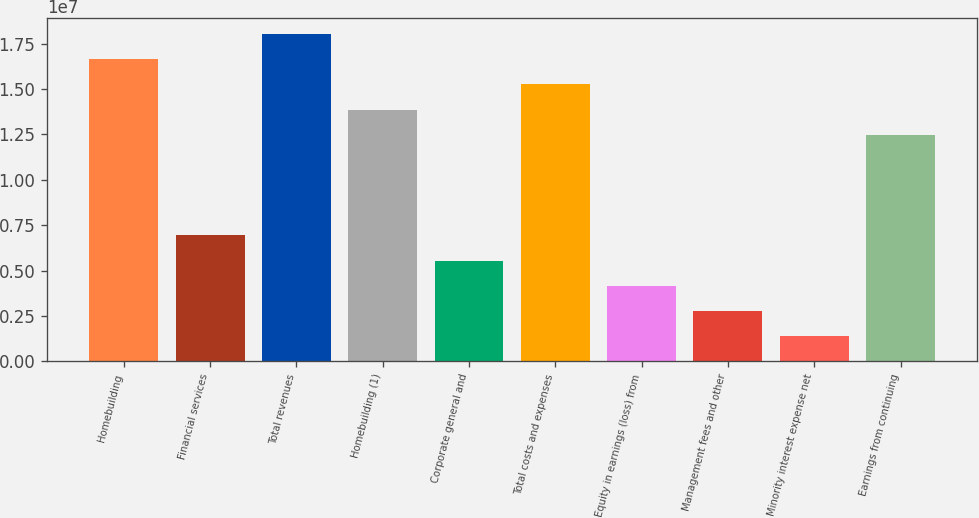Convert chart. <chart><loc_0><loc_0><loc_500><loc_500><bar_chart><fcel>Homebuilding<fcel>Financial services<fcel>Total revenues<fcel>Homebuilding (1)<fcel>Corporate general and<fcel>Total costs and expenses<fcel>Equity in earnings (loss) from<fcel>Management fees and other<fcel>Minority interest expense net<fcel>Earnings from continuing<nl><fcel>1.66404e+07<fcel>6.93349e+06<fcel>1.80271e+07<fcel>1.3867e+07<fcel>5.54679e+06<fcel>1.52537e+07<fcel>4.1601e+06<fcel>2.7734e+06<fcel>1.3867e+06<fcel>1.24803e+07<nl></chart> 